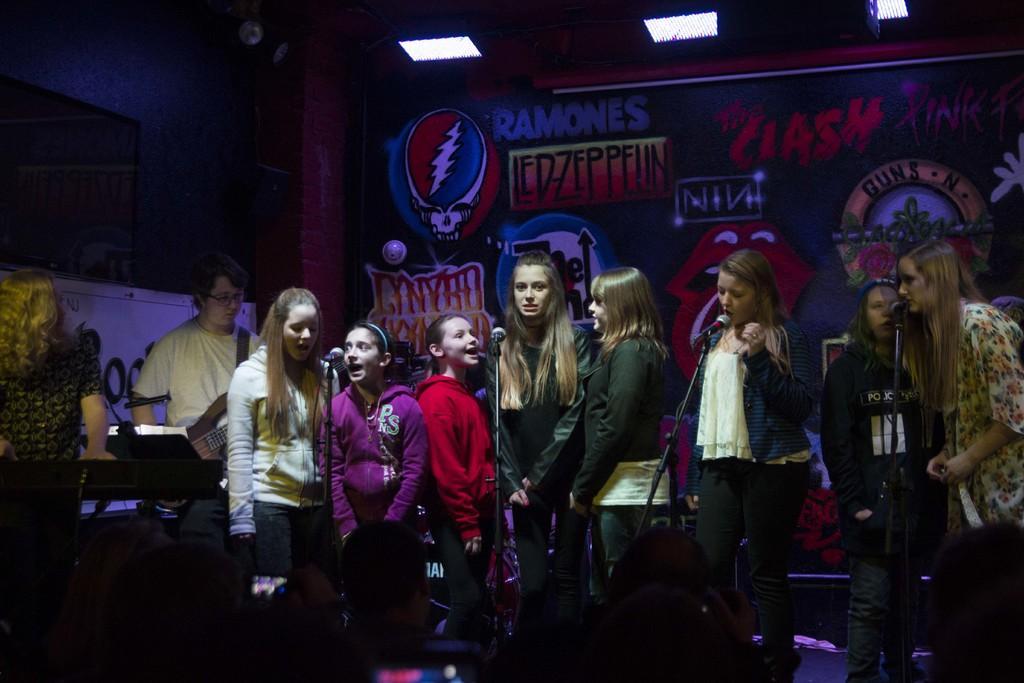Describe this image in one or two sentences. In this picture we can see a group of people, here we can see mics, lights, banners and some objects. 